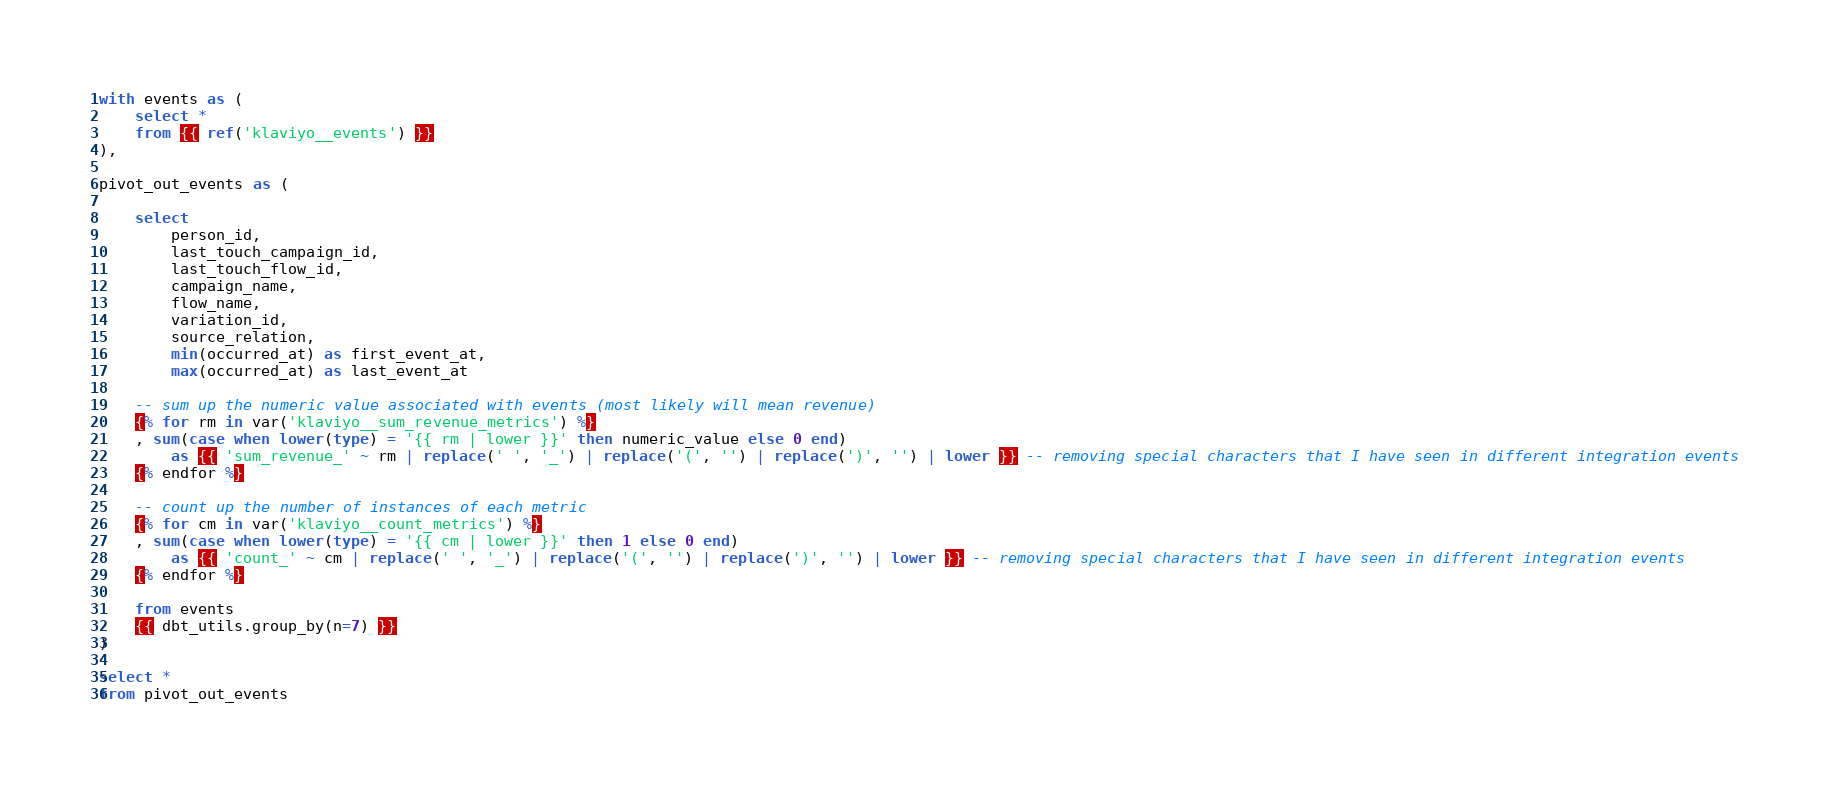<code> <loc_0><loc_0><loc_500><loc_500><_SQL_>with events as (
    select *
    from {{ ref('klaviyo__events') }}
),

pivot_out_events as (
    
    select 
        person_id,
        last_touch_campaign_id,
        last_touch_flow_id,
        campaign_name,
        flow_name,
        variation_id,
        source_relation,
        min(occurred_at) as first_event_at,
        max(occurred_at) as last_event_at

    -- sum up the numeric value associated with events (most likely will mean revenue)
    {% for rm in var('klaviyo__sum_revenue_metrics') %}
    , sum(case when lower(type) = '{{ rm | lower }}' then numeric_value else 0 end) 
        as {{ 'sum_revenue_' ~ rm | replace(' ', '_') | replace('(', '') | replace(')', '') | lower }} -- removing special characters that I have seen in different integration events
    {% endfor %}

    -- count up the number of instances of each metric
    {% for cm in var('klaviyo__count_metrics') %}
    , sum(case when lower(type) = '{{ cm | lower }}' then 1 else 0 end) 
        as {{ 'count_' ~ cm | replace(' ', '_') | replace('(', '') | replace(')', '') | lower }} -- removing special characters that I have seen in different integration events
    {% endfor %}

    from events
    {{ dbt_utils.group_by(n=7) }}
)

select *
from pivot_out_events</code> 